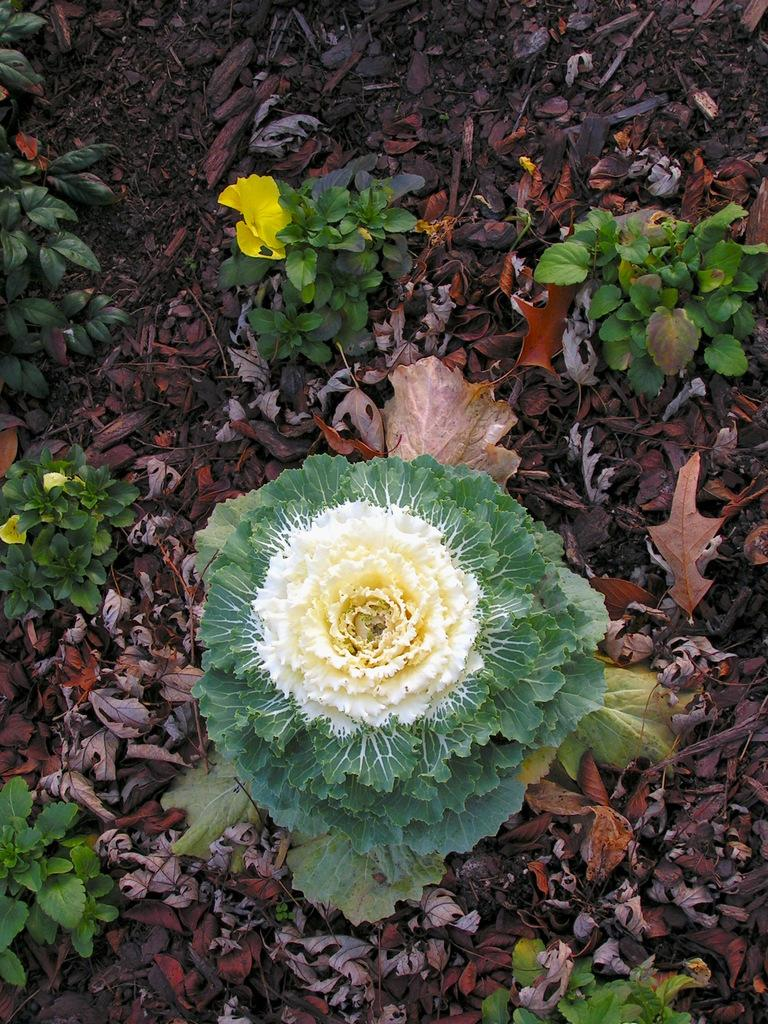What is the primary feature of the surface in the image? The surface in the image has dried leaves on it. What type of plants can be seen in the image? There are small plants with yellow flowers in the image. Are there any specific characteristics of the flowers? One flower has thorns in the image. What type of hammer is being used to create clouds in the image? There is no hammer or clouds present in the image; it features a surface with dried leaves and small plants with yellow flowers. 